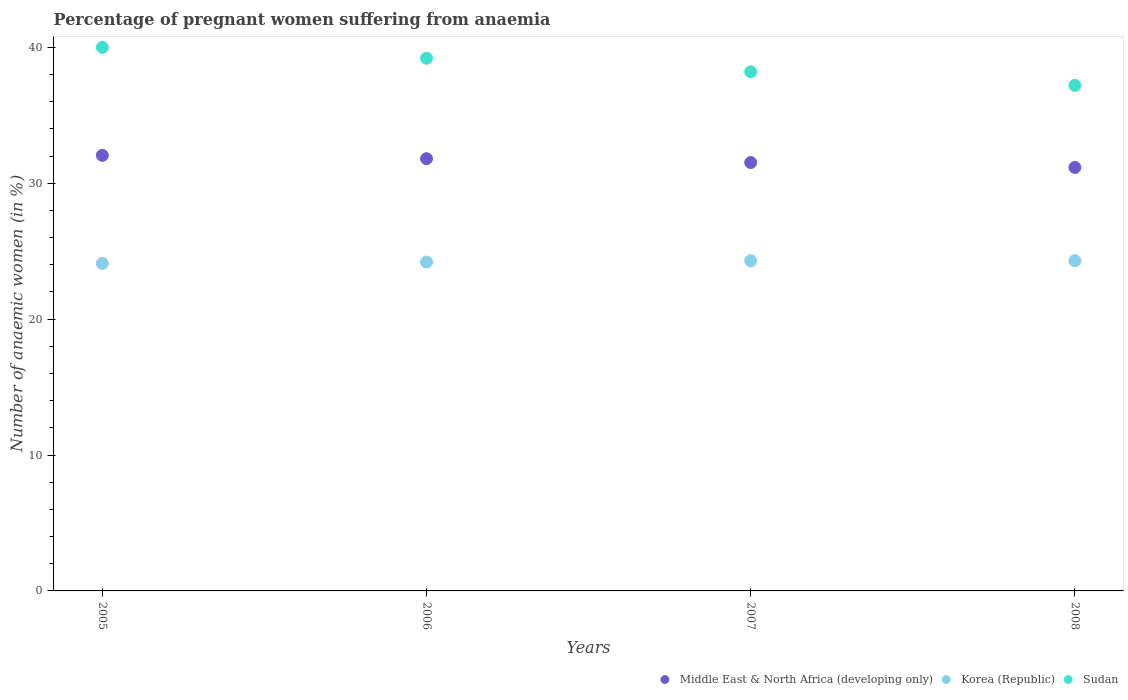What is the number of anaemic women in Middle East & North Africa (developing only) in 2006?
Give a very brief answer. 31.81. Across all years, what is the maximum number of anaemic women in Korea (Republic)?
Provide a succinct answer. 24.3. Across all years, what is the minimum number of anaemic women in Middle East & North Africa (developing only)?
Make the answer very short. 31.16. In which year was the number of anaemic women in Middle East & North Africa (developing only) maximum?
Provide a succinct answer. 2005. What is the total number of anaemic women in Sudan in the graph?
Provide a succinct answer. 154.6. What is the difference between the number of anaemic women in Sudan in 2005 and that in 2008?
Offer a terse response. 2.8. What is the difference between the number of anaemic women in Sudan in 2006 and the number of anaemic women in Korea (Republic) in 2005?
Provide a short and direct response. 15.1. What is the average number of anaemic women in Sudan per year?
Give a very brief answer. 38.65. In the year 2006, what is the difference between the number of anaemic women in Middle East & North Africa (developing only) and number of anaemic women in Sudan?
Make the answer very short. -7.39. What is the ratio of the number of anaemic women in Sudan in 2006 to that in 2007?
Your response must be concise. 1.03. What is the difference between the highest and the second highest number of anaemic women in Middle East & North Africa (developing only)?
Give a very brief answer. 0.25. What is the difference between the highest and the lowest number of anaemic women in Middle East & North Africa (developing only)?
Keep it short and to the point. 0.89. In how many years, is the number of anaemic women in Sudan greater than the average number of anaemic women in Sudan taken over all years?
Make the answer very short. 2. Is it the case that in every year, the sum of the number of anaemic women in Middle East & North Africa (developing only) and number of anaemic women in Korea (Republic)  is greater than the number of anaemic women in Sudan?
Offer a terse response. Yes. Does the number of anaemic women in Middle East & North Africa (developing only) monotonically increase over the years?
Ensure brevity in your answer.  No. How many dotlines are there?
Your answer should be compact. 3. How many years are there in the graph?
Your answer should be very brief. 4. Does the graph contain grids?
Your response must be concise. No. Where does the legend appear in the graph?
Your response must be concise. Bottom right. What is the title of the graph?
Offer a very short reply. Percentage of pregnant women suffering from anaemia. Does "Lebanon" appear as one of the legend labels in the graph?
Make the answer very short. No. What is the label or title of the X-axis?
Give a very brief answer. Years. What is the label or title of the Y-axis?
Keep it short and to the point. Number of anaemic women (in %). What is the Number of anaemic women (in %) of Middle East & North Africa (developing only) in 2005?
Give a very brief answer. 32.05. What is the Number of anaemic women (in %) in Korea (Republic) in 2005?
Keep it short and to the point. 24.1. What is the Number of anaemic women (in %) in Middle East & North Africa (developing only) in 2006?
Keep it short and to the point. 31.81. What is the Number of anaemic women (in %) in Korea (Republic) in 2006?
Provide a succinct answer. 24.2. What is the Number of anaemic women (in %) in Sudan in 2006?
Your answer should be compact. 39.2. What is the Number of anaemic women (in %) of Middle East & North Africa (developing only) in 2007?
Provide a succinct answer. 31.53. What is the Number of anaemic women (in %) in Korea (Republic) in 2007?
Your answer should be very brief. 24.3. What is the Number of anaemic women (in %) of Sudan in 2007?
Your answer should be very brief. 38.2. What is the Number of anaemic women (in %) in Middle East & North Africa (developing only) in 2008?
Offer a very short reply. 31.16. What is the Number of anaemic women (in %) in Korea (Republic) in 2008?
Your answer should be compact. 24.3. What is the Number of anaemic women (in %) of Sudan in 2008?
Make the answer very short. 37.2. Across all years, what is the maximum Number of anaemic women (in %) in Middle East & North Africa (developing only)?
Your answer should be compact. 32.05. Across all years, what is the maximum Number of anaemic women (in %) of Korea (Republic)?
Your answer should be compact. 24.3. Across all years, what is the maximum Number of anaemic women (in %) of Sudan?
Give a very brief answer. 40. Across all years, what is the minimum Number of anaemic women (in %) of Middle East & North Africa (developing only)?
Give a very brief answer. 31.16. Across all years, what is the minimum Number of anaemic women (in %) of Korea (Republic)?
Offer a terse response. 24.1. Across all years, what is the minimum Number of anaemic women (in %) in Sudan?
Give a very brief answer. 37.2. What is the total Number of anaemic women (in %) in Middle East & North Africa (developing only) in the graph?
Provide a short and direct response. 126.55. What is the total Number of anaemic women (in %) of Korea (Republic) in the graph?
Ensure brevity in your answer.  96.9. What is the total Number of anaemic women (in %) in Sudan in the graph?
Make the answer very short. 154.6. What is the difference between the Number of anaemic women (in %) in Middle East & North Africa (developing only) in 2005 and that in 2006?
Give a very brief answer. 0.25. What is the difference between the Number of anaemic women (in %) of Korea (Republic) in 2005 and that in 2006?
Give a very brief answer. -0.1. What is the difference between the Number of anaemic women (in %) in Middle East & North Africa (developing only) in 2005 and that in 2007?
Provide a succinct answer. 0.53. What is the difference between the Number of anaemic women (in %) of Sudan in 2005 and that in 2007?
Make the answer very short. 1.8. What is the difference between the Number of anaemic women (in %) in Middle East & North Africa (developing only) in 2005 and that in 2008?
Ensure brevity in your answer.  0.89. What is the difference between the Number of anaemic women (in %) in Korea (Republic) in 2005 and that in 2008?
Keep it short and to the point. -0.2. What is the difference between the Number of anaemic women (in %) of Sudan in 2005 and that in 2008?
Make the answer very short. 2.8. What is the difference between the Number of anaemic women (in %) of Middle East & North Africa (developing only) in 2006 and that in 2007?
Offer a terse response. 0.28. What is the difference between the Number of anaemic women (in %) in Sudan in 2006 and that in 2007?
Your response must be concise. 1. What is the difference between the Number of anaemic women (in %) in Middle East & North Africa (developing only) in 2006 and that in 2008?
Keep it short and to the point. 0.64. What is the difference between the Number of anaemic women (in %) in Korea (Republic) in 2006 and that in 2008?
Offer a very short reply. -0.1. What is the difference between the Number of anaemic women (in %) in Sudan in 2006 and that in 2008?
Give a very brief answer. 2. What is the difference between the Number of anaemic women (in %) of Middle East & North Africa (developing only) in 2007 and that in 2008?
Your response must be concise. 0.36. What is the difference between the Number of anaemic women (in %) of Korea (Republic) in 2007 and that in 2008?
Offer a terse response. 0. What is the difference between the Number of anaemic women (in %) of Sudan in 2007 and that in 2008?
Keep it short and to the point. 1. What is the difference between the Number of anaemic women (in %) of Middle East & North Africa (developing only) in 2005 and the Number of anaemic women (in %) of Korea (Republic) in 2006?
Ensure brevity in your answer.  7.85. What is the difference between the Number of anaemic women (in %) of Middle East & North Africa (developing only) in 2005 and the Number of anaemic women (in %) of Sudan in 2006?
Make the answer very short. -7.15. What is the difference between the Number of anaemic women (in %) in Korea (Republic) in 2005 and the Number of anaemic women (in %) in Sudan in 2006?
Give a very brief answer. -15.1. What is the difference between the Number of anaemic women (in %) in Middle East & North Africa (developing only) in 2005 and the Number of anaemic women (in %) in Korea (Republic) in 2007?
Provide a short and direct response. 7.75. What is the difference between the Number of anaemic women (in %) in Middle East & North Africa (developing only) in 2005 and the Number of anaemic women (in %) in Sudan in 2007?
Offer a very short reply. -6.15. What is the difference between the Number of anaemic women (in %) in Korea (Republic) in 2005 and the Number of anaemic women (in %) in Sudan in 2007?
Keep it short and to the point. -14.1. What is the difference between the Number of anaemic women (in %) in Middle East & North Africa (developing only) in 2005 and the Number of anaemic women (in %) in Korea (Republic) in 2008?
Give a very brief answer. 7.75. What is the difference between the Number of anaemic women (in %) in Middle East & North Africa (developing only) in 2005 and the Number of anaemic women (in %) in Sudan in 2008?
Provide a succinct answer. -5.15. What is the difference between the Number of anaemic women (in %) of Korea (Republic) in 2005 and the Number of anaemic women (in %) of Sudan in 2008?
Your answer should be very brief. -13.1. What is the difference between the Number of anaemic women (in %) in Middle East & North Africa (developing only) in 2006 and the Number of anaemic women (in %) in Korea (Republic) in 2007?
Offer a very short reply. 7.51. What is the difference between the Number of anaemic women (in %) in Middle East & North Africa (developing only) in 2006 and the Number of anaemic women (in %) in Sudan in 2007?
Ensure brevity in your answer.  -6.39. What is the difference between the Number of anaemic women (in %) of Middle East & North Africa (developing only) in 2006 and the Number of anaemic women (in %) of Korea (Republic) in 2008?
Make the answer very short. 7.51. What is the difference between the Number of anaemic women (in %) of Middle East & North Africa (developing only) in 2006 and the Number of anaemic women (in %) of Sudan in 2008?
Your answer should be compact. -5.39. What is the difference between the Number of anaemic women (in %) of Middle East & North Africa (developing only) in 2007 and the Number of anaemic women (in %) of Korea (Republic) in 2008?
Keep it short and to the point. 7.23. What is the difference between the Number of anaemic women (in %) in Middle East & North Africa (developing only) in 2007 and the Number of anaemic women (in %) in Sudan in 2008?
Offer a terse response. -5.67. What is the difference between the Number of anaemic women (in %) of Korea (Republic) in 2007 and the Number of anaemic women (in %) of Sudan in 2008?
Your answer should be compact. -12.9. What is the average Number of anaemic women (in %) in Middle East & North Africa (developing only) per year?
Provide a short and direct response. 31.64. What is the average Number of anaemic women (in %) in Korea (Republic) per year?
Ensure brevity in your answer.  24.23. What is the average Number of anaemic women (in %) of Sudan per year?
Ensure brevity in your answer.  38.65. In the year 2005, what is the difference between the Number of anaemic women (in %) in Middle East & North Africa (developing only) and Number of anaemic women (in %) in Korea (Republic)?
Offer a terse response. 7.95. In the year 2005, what is the difference between the Number of anaemic women (in %) of Middle East & North Africa (developing only) and Number of anaemic women (in %) of Sudan?
Offer a terse response. -7.95. In the year 2005, what is the difference between the Number of anaemic women (in %) of Korea (Republic) and Number of anaemic women (in %) of Sudan?
Offer a very short reply. -15.9. In the year 2006, what is the difference between the Number of anaemic women (in %) in Middle East & North Africa (developing only) and Number of anaemic women (in %) in Korea (Republic)?
Ensure brevity in your answer.  7.61. In the year 2006, what is the difference between the Number of anaemic women (in %) in Middle East & North Africa (developing only) and Number of anaemic women (in %) in Sudan?
Offer a terse response. -7.39. In the year 2006, what is the difference between the Number of anaemic women (in %) in Korea (Republic) and Number of anaemic women (in %) in Sudan?
Your answer should be very brief. -15. In the year 2007, what is the difference between the Number of anaemic women (in %) of Middle East & North Africa (developing only) and Number of anaemic women (in %) of Korea (Republic)?
Offer a terse response. 7.23. In the year 2007, what is the difference between the Number of anaemic women (in %) of Middle East & North Africa (developing only) and Number of anaemic women (in %) of Sudan?
Ensure brevity in your answer.  -6.67. In the year 2008, what is the difference between the Number of anaemic women (in %) of Middle East & North Africa (developing only) and Number of anaemic women (in %) of Korea (Republic)?
Your answer should be very brief. 6.86. In the year 2008, what is the difference between the Number of anaemic women (in %) of Middle East & North Africa (developing only) and Number of anaemic women (in %) of Sudan?
Provide a short and direct response. -6.04. In the year 2008, what is the difference between the Number of anaemic women (in %) in Korea (Republic) and Number of anaemic women (in %) in Sudan?
Your answer should be very brief. -12.9. What is the ratio of the Number of anaemic women (in %) in Middle East & North Africa (developing only) in 2005 to that in 2006?
Make the answer very short. 1.01. What is the ratio of the Number of anaemic women (in %) in Korea (Republic) in 2005 to that in 2006?
Provide a succinct answer. 1. What is the ratio of the Number of anaemic women (in %) of Sudan in 2005 to that in 2006?
Provide a short and direct response. 1.02. What is the ratio of the Number of anaemic women (in %) of Middle East & North Africa (developing only) in 2005 to that in 2007?
Provide a short and direct response. 1.02. What is the ratio of the Number of anaemic women (in %) in Korea (Republic) in 2005 to that in 2007?
Your answer should be compact. 0.99. What is the ratio of the Number of anaemic women (in %) in Sudan in 2005 to that in 2007?
Your response must be concise. 1.05. What is the ratio of the Number of anaemic women (in %) in Middle East & North Africa (developing only) in 2005 to that in 2008?
Keep it short and to the point. 1.03. What is the ratio of the Number of anaemic women (in %) of Korea (Republic) in 2005 to that in 2008?
Your response must be concise. 0.99. What is the ratio of the Number of anaemic women (in %) in Sudan in 2005 to that in 2008?
Offer a terse response. 1.08. What is the ratio of the Number of anaemic women (in %) of Middle East & North Africa (developing only) in 2006 to that in 2007?
Give a very brief answer. 1.01. What is the ratio of the Number of anaemic women (in %) in Korea (Republic) in 2006 to that in 2007?
Provide a short and direct response. 1. What is the ratio of the Number of anaemic women (in %) in Sudan in 2006 to that in 2007?
Provide a short and direct response. 1.03. What is the ratio of the Number of anaemic women (in %) of Middle East & North Africa (developing only) in 2006 to that in 2008?
Ensure brevity in your answer.  1.02. What is the ratio of the Number of anaemic women (in %) in Korea (Republic) in 2006 to that in 2008?
Provide a short and direct response. 1. What is the ratio of the Number of anaemic women (in %) of Sudan in 2006 to that in 2008?
Provide a succinct answer. 1.05. What is the ratio of the Number of anaemic women (in %) of Middle East & North Africa (developing only) in 2007 to that in 2008?
Your response must be concise. 1.01. What is the ratio of the Number of anaemic women (in %) in Sudan in 2007 to that in 2008?
Your response must be concise. 1.03. What is the difference between the highest and the second highest Number of anaemic women (in %) of Middle East & North Africa (developing only)?
Make the answer very short. 0.25. What is the difference between the highest and the lowest Number of anaemic women (in %) of Middle East & North Africa (developing only)?
Your response must be concise. 0.89. What is the difference between the highest and the lowest Number of anaemic women (in %) in Korea (Republic)?
Provide a short and direct response. 0.2. What is the difference between the highest and the lowest Number of anaemic women (in %) in Sudan?
Offer a terse response. 2.8. 